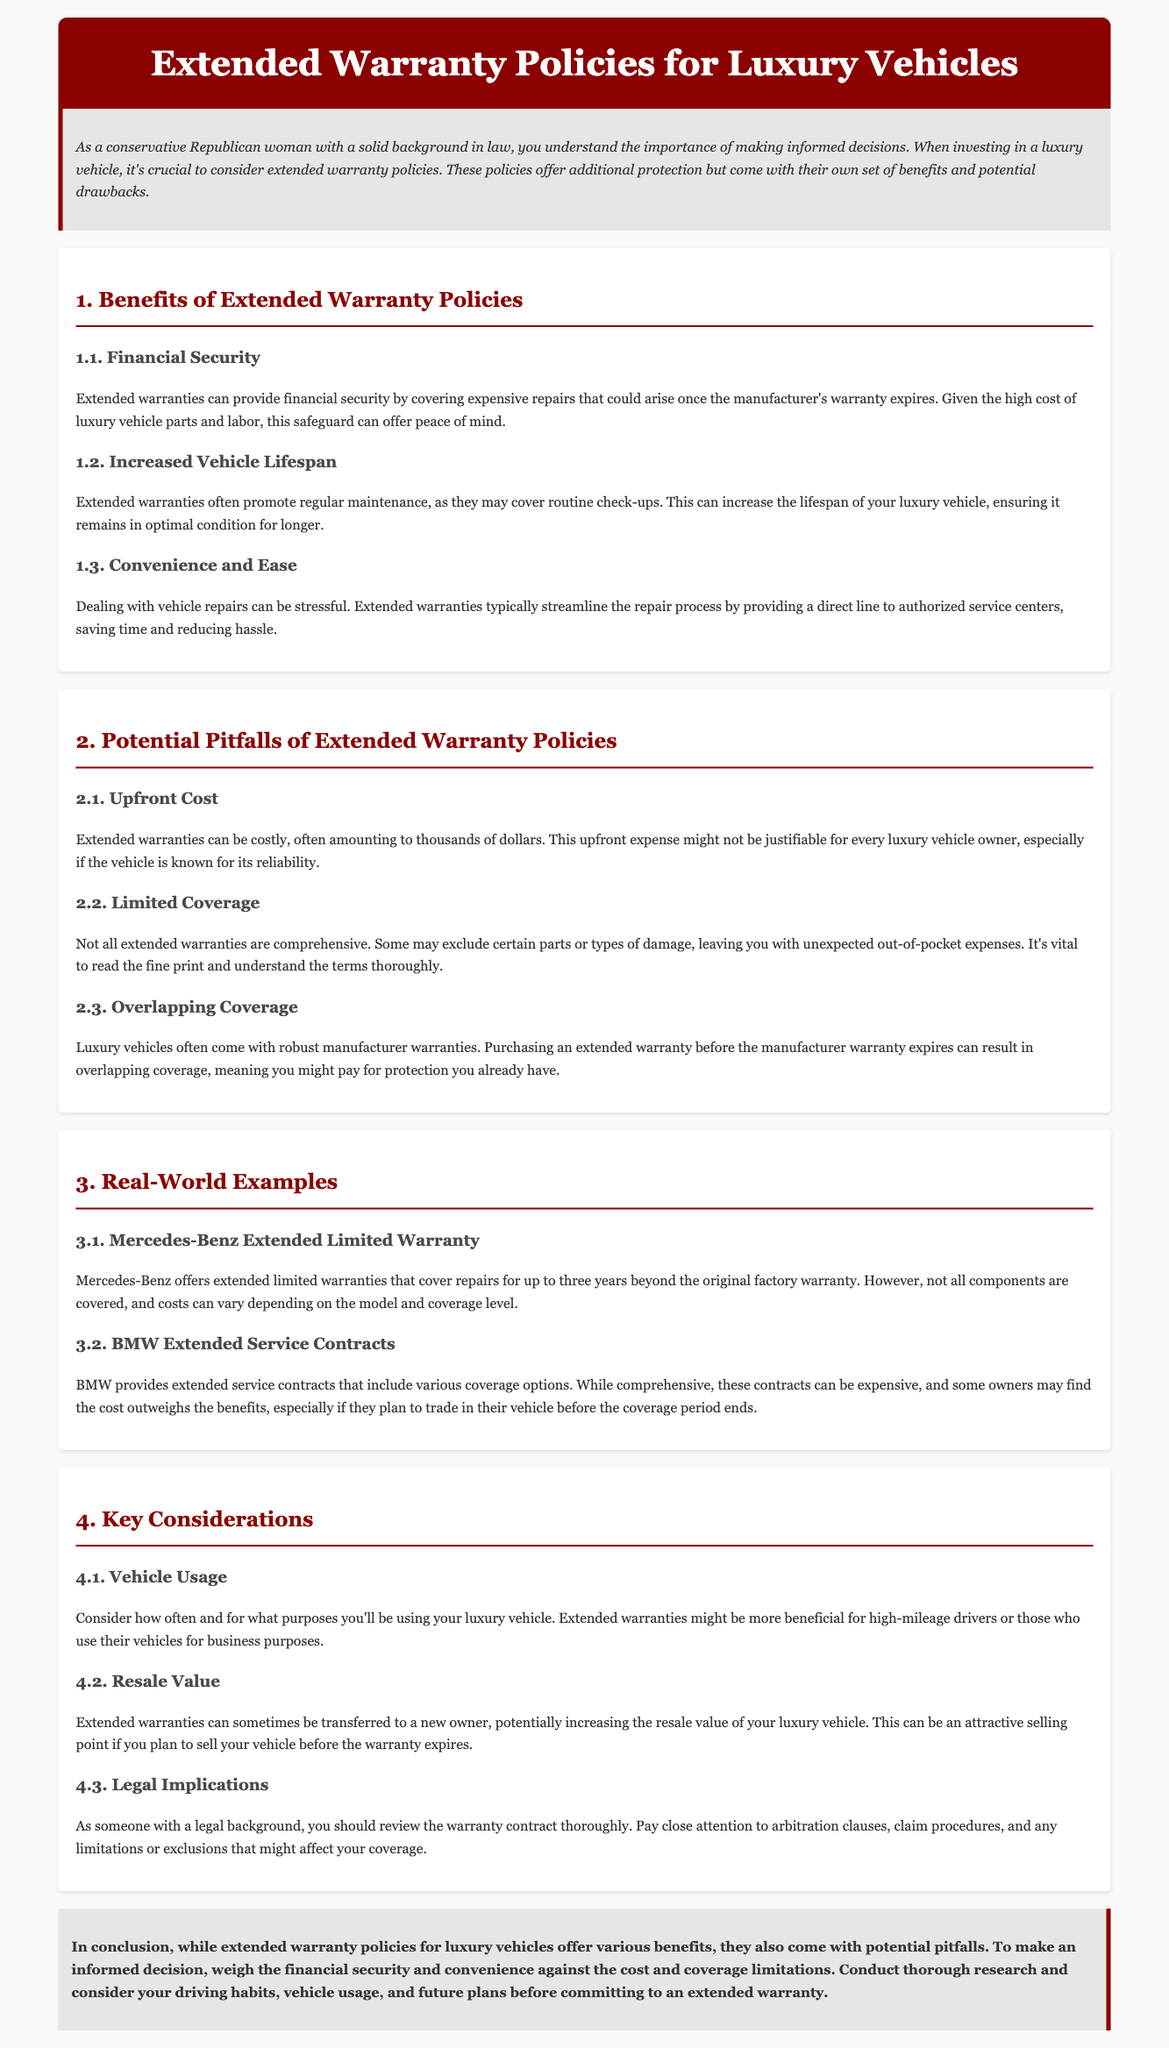what is the primary benefit of extended warranties? The primary benefit mentioned in the document is financial security, as it can cover expensive repairs after the manufacturer's warranty expires.
Answer: financial security what can extended warranties increase for luxury vehicles? One of the benefits listed is that extended warranties can increase the lifespan of luxury vehicles by promoting regular maintenance.
Answer: vehicle lifespan what is a potential pitfall of extended warranty policies? One noted pitfall is the upfront cost, which can often amount to thousands of dollars.
Answer: upfront cost how long does the Mercedes-Benz extended limited warranty cover repairs? The document states that the Mercedes-Benz extended limited warranty covers repairs for up to three years beyond the original factory warranty.
Answer: three years what should one pay close attention to in warranty contracts? The document advises reviewing the warranty contract thoroughly, particularly the arbitration clauses, claim procedures, and any limitations or exclusions.
Answer: arbitration clauses what factor can make extended warranties more beneficial? The document mentions that extended warranties might be more beneficial for high-mileage drivers or those using their vehicles for business purposes.
Answer: vehicle usage what aspect can potentially increase the resale value of a luxury vehicle? The ability to transfer extended warranties to new owners can potentially increase the resale value of luxury vehicles.
Answer: transferable warranties what do BMW extended service contracts include? The document indicates that BMW provides extended service contracts that include various coverage options.
Answer: various coverage options what might some extended warranties exclude? Some extended warranties may exclude certain parts or types of damage, leading to unexpected out-of-pocket expenses.
Answer: certain parts or types of damage 